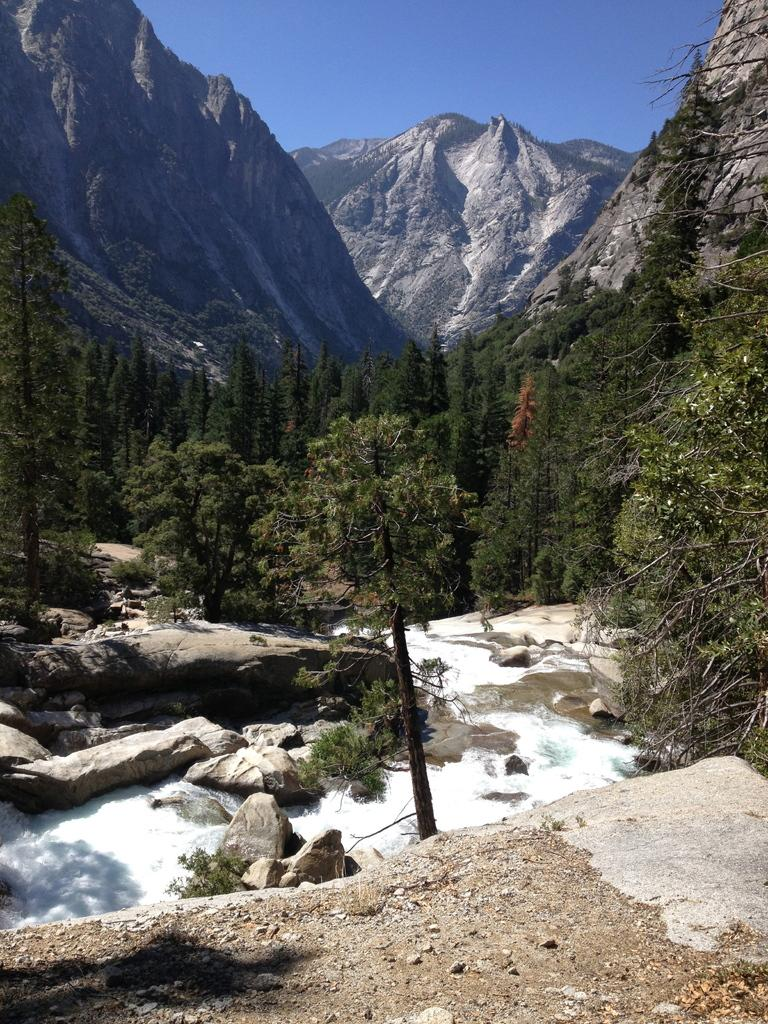What is happening to the water in the image? The water is flowing over rocks in the image. What can be seen in the background of the image? There are trees and mountains visible in the background of the image. What type of basketball court can be seen in the image? There is no basketball court present in the image; it features flowing water over rocks and a background with trees and mountains. 